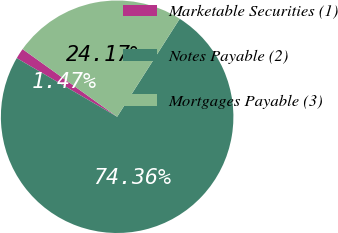Convert chart. <chart><loc_0><loc_0><loc_500><loc_500><pie_chart><fcel>Marketable Securities (1)<fcel>Notes Payable (2)<fcel>Mortgages Payable (3)<nl><fcel>1.47%<fcel>74.37%<fcel>24.17%<nl></chart> 